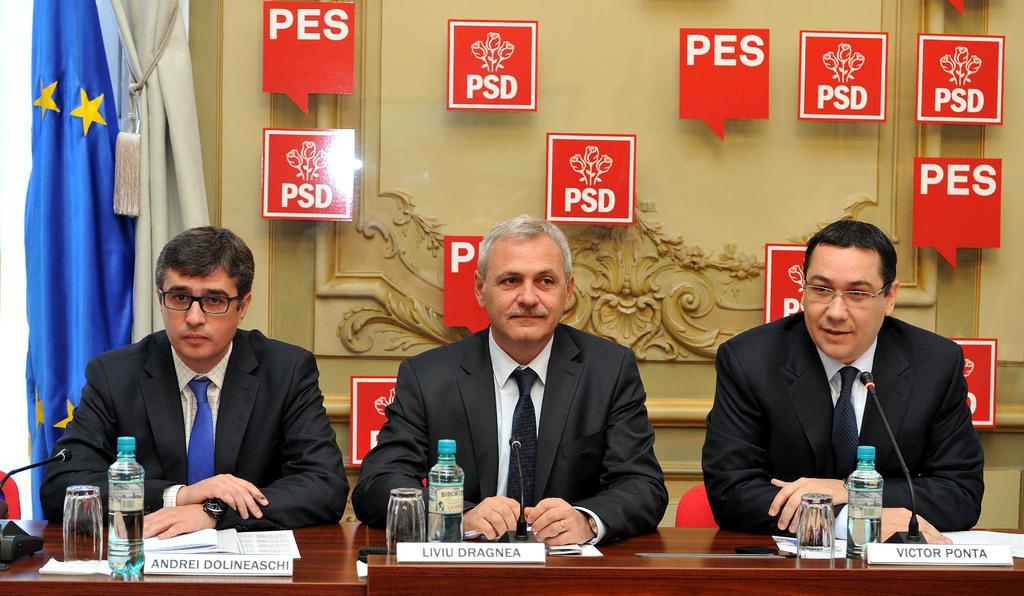Please provide a concise description of this image. In this image we can see persons sitting at the table. On the table we can see name boards, water bottles, mics and glass tumblers. In the background we can see flag and wall. 